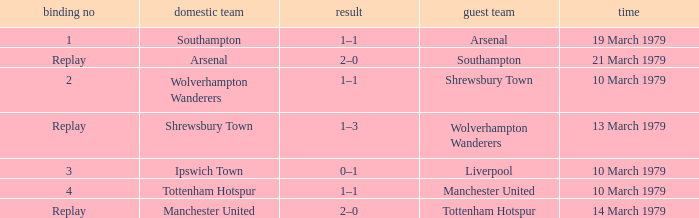What was the score for the tie that had Shrewsbury Town as home team? 1–3. 